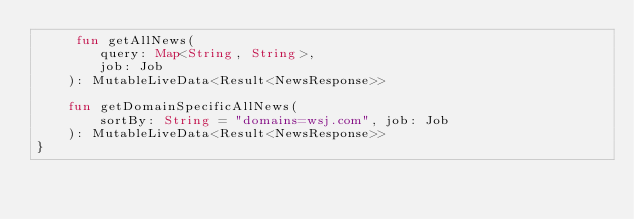Convert code to text. <code><loc_0><loc_0><loc_500><loc_500><_Kotlin_>     fun getAllNews(
        query: Map<String, String>,
        job: Job
    ): MutableLiveData<Result<NewsResponse>>

    fun getDomainSpecificAllNews(
        sortBy: String = "domains=wsj.com", job: Job
    ): MutableLiveData<Result<NewsResponse>>
}</code> 